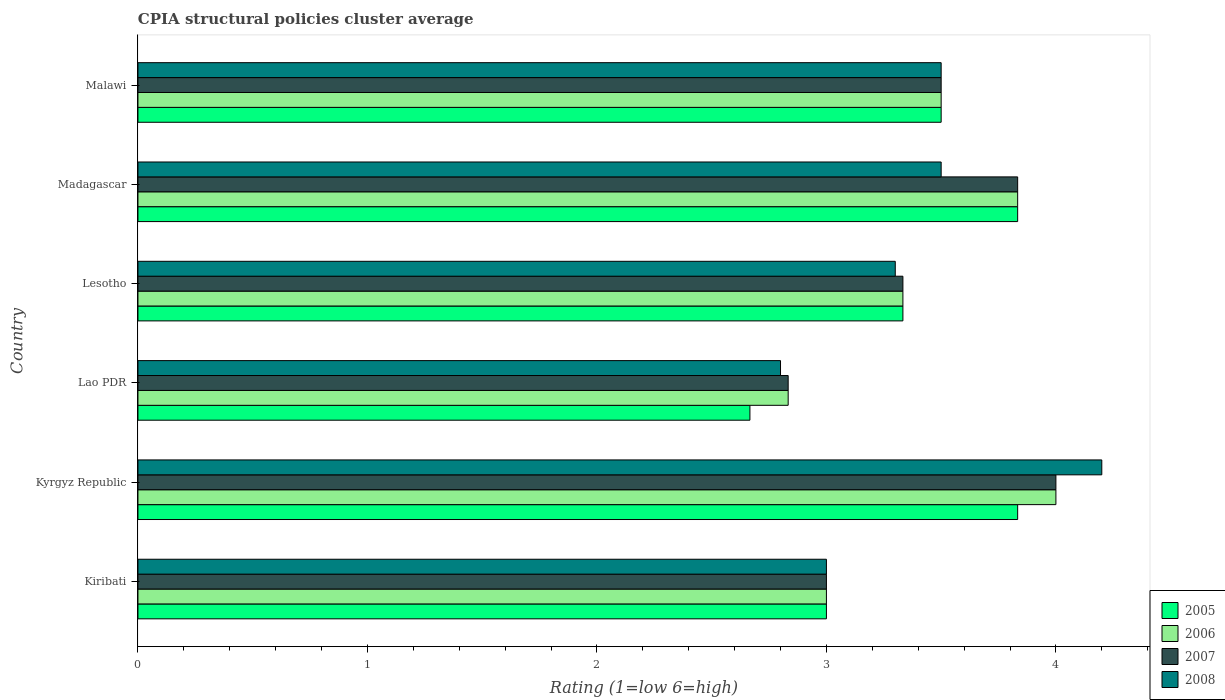How many different coloured bars are there?
Give a very brief answer. 4. How many groups of bars are there?
Your answer should be compact. 6. Are the number of bars per tick equal to the number of legend labels?
Ensure brevity in your answer.  Yes. How many bars are there on the 5th tick from the bottom?
Make the answer very short. 4. What is the label of the 3rd group of bars from the top?
Offer a terse response. Lesotho. What is the CPIA rating in 2005 in Kyrgyz Republic?
Your answer should be compact. 3.83. Across all countries, what is the minimum CPIA rating in 2006?
Give a very brief answer. 2.83. In which country was the CPIA rating in 2007 maximum?
Make the answer very short. Kyrgyz Republic. In which country was the CPIA rating in 2008 minimum?
Keep it short and to the point. Lao PDR. What is the total CPIA rating in 2005 in the graph?
Your answer should be compact. 20.17. What is the difference between the CPIA rating in 2006 in Lesotho and the CPIA rating in 2008 in Kiribati?
Your answer should be compact. 0.33. What is the average CPIA rating in 2007 per country?
Offer a terse response. 3.42. What is the difference between the CPIA rating in 2008 and CPIA rating in 2005 in Kyrgyz Republic?
Make the answer very short. 0.37. What is the ratio of the CPIA rating in 2005 in Madagascar to that in Malawi?
Provide a short and direct response. 1.1. Is the CPIA rating in 2005 in Lesotho less than that in Madagascar?
Your answer should be compact. Yes. Is the difference between the CPIA rating in 2008 in Kiribati and Kyrgyz Republic greater than the difference between the CPIA rating in 2005 in Kiribati and Kyrgyz Republic?
Give a very brief answer. No. What is the difference between the highest and the second highest CPIA rating in 2008?
Provide a succinct answer. 0.7. What is the difference between the highest and the lowest CPIA rating in 2008?
Ensure brevity in your answer.  1.4. What does the 3rd bar from the top in Lao PDR represents?
Your response must be concise. 2006. Is it the case that in every country, the sum of the CPIA rating in 2007 and CPIA rating in 2006 is greater than the CPIA rating in 2005?
Provide a short and direct response. Yes. Are all the bars in the graph horizontal?
Your response must be concise. Yes. How many countries are there in the graph?
Make the answer very short. 6. What is the difference between two consecutive major ticks on the X-axis?
Make the answer very short. 1. Are the values on the major ticks of X-axis written in scientific E-notation?
Give a very brief answer. No. Where does the legend appear in the graph?
Provide a short and direct response. Bottom right. How many legend labels are there?
Offer a very short reply. 4. What is the title of the graph?
Provide a short and direct response. CPIA structural policies cluster average. What is the label or title of the X-axis?
Keep it short and to the point. Rating (1=low 6=high). What is the Rating (1=low 6=high) in 2005 in Kiribati?
Offer a terse response. 3. What is the Rating (1=low 6=high) of 2006 in Kiribati?
Offer a terse response. 3. What is the Rating (1=low 6=high) of 2005 in Kyrgyz Republic?
Keep it short and to the point. 3.83. What is the Rating (1=low 6=high) of 2006 in Kyrgyz Republic?
Your response must be concise. 4. What is the Rating (1=low 6=high) of 2008 in Kyrgyz Republic?
Provide a short and direct response. 4.2. What is the Rating (1=low 6=high) in 2005 in Lao PDR?
Give a very brief answer. 2.67. What is the Rating (1=low 6=high) of 2006 in Lao PDR?
Offer a very short reply. 2.83. What is the Rating (1=low 6=high) of 2007 in Lao PDR?
Offer a very short reply. 2.83. What is the Rating (1=low 6=high) in 2008 in Lao PDR?
Your answer should be very brief. 2.8. What is the Rating (1=low 6=high) in 2005 in Lesotho?
Your answer should be compact. 3.33. What is the Rating (1=low 6=high) of 2006 in Lesotho?
Provide a short and direct response. 3.33. What is the Rating (1=low 6=high) in 2007 in Lesotho?
Give a very brief answer. 3.33. What is the Rating (1=low 6=high) in 2008 in Lesotho?
Provide a succinct answer. 3.3. What is the Rating (1=low 6=high) of 2005 in Madagascar?
Offer a very short reply. 3.83. What is the Rating (1=low 6=high) of 2006 in Madagascar?
Ensure brevity in your answer.  3.83. What is the Rating (1=low 6=high) in 2007 in Madagascar?
Offer a very short reply. 3.83. What is the Rating (1=low 6=high) of 2008 in Madagascar?
Offer a terse response. 3.5. What is the Rating (1=low 6=high) in 2006 in Malawi?
Give a very brief answer. 3.5. What is the Rating (1=low 6=high) of 2008 in Malawi?
Your response must be concise. 3.5. Across all countries, what is the maximum Rating (1=low 6=high) in 2005?
Offer a very short reply. 3.83. Across all countries, what is the maximum Rating (1=low 6=high) in 2007?
Your response must be concise. 4. Across all countries, what is the minimum Rating (1=low 6=high) of 2005?
Give a very brief answer. 2.67. Across all countries, what is the minimum Rating (1=low 6=high) of 2006?
Keep it short and to the point. 2.83. Across all countries, what is the minimum Rating (1=low 6=high) of 2007?
Give a very brief answer. 2.83. What is the total Rating (1=low 6=high) of 2005 in the graph?
Provide a succinct answer. 20.17. What is the total Rating (1=low 6=high) of 2006 in the graph?
Keep it short and to the point. 20.5. What is the total Rating (1=low 6=high) of 2008 in the graph?
Your response must be concise. 20.3. What is the difference between the Rating (1=low 6=high) in 2005 in Kiribati and that in Kyrgyz Republic?
Keep it short and to the point. -0.83. What is the difference between the Rating (1=low 6=high) in 2006 in Kiribati and that in Kyrgyz Republic?
Offer a terse response. -1. What is the difference between the Rating (1=low 6=high) of 2007 in Kiribati and that in Lao PDR?
Ensure brevity in your answer.  0.17. What is the difference between the Rating (1=low 6=high) in 2006 in Kiribati and that in Madagascar?
Offer a very short reply. -0.83. What is the difference between the Rating (1=low 6=high) of 2007 in Kiribati and that in Madagascar?
Offer a terse response. -0.83. What is the difference between the Rating (1=low 6=high) in 2007 in Kiribati and that in Malawi?
Provide a succinct answer. -0.5. What is the difference between the Rating (1=low 6=high) in 2008 in Kiribati and that in Malawi?
Give a very brief answer. -0.5. What is the difference between the Rating (1=low 6=high) of 2006 in Kyrgyz Republic and that in Lao PDR?
Your response must be concise. 1.17. What is the difference between the Rating (1=low 6=high) of 2007 in Kyrgyz Republic and that in Lao PDR?
Your answer should be compact. 1.17. What is the difference between the Rating (1=low 6=high) of 2008 in Kyrgyz Republic and that in Lao PDR?
Provide a short and direct response. 1.4. What is the difference between the Rating (1=low 6=high) of 2005 in Kyrgyz Republic and that in Madagascar?
Keep it short and to the point. 0. What is the difference between the Rating (1=low 6=high) in 2006 in Kyrgyz Republic and that in Madagascar?
Ensure brevity in your answer.  0.17. What is the difference between the Rating (1=low 6=high) in 2008 in Kyrgyz Republic and that in Madagascar?
Your response must be concise. 0.7. What is the difference between the Rating (1=low 6=high) in 2005 in Kyrgyz Republic and that in Malawi?
Provide a succinct answer. 0.33. What is the difference between the Rating (1=low 6=high) of 2008 in Kyrgyz Republic and that in Malawi?
Keep it short and to the point. 0.7. What is the difference between the Rating (1=low 6=high) of 2005 in Lao PDR and that in Lesotho?
Your answer should be compact. -0.67. What is the difference between the Rating (1=low 6=high) in 2006 in Lao PDR and that in Lesotho?
Keep it short and to the point. -0.5. What is the difference between the Rating (1=low 6=high) in 2007 in Lao PDR and that in Lesotho?
Your response must be concise. -0.5. What is the difference between the Rating (1=low 6=high) of 2008 in Lao PDR and that in Lesotho?
Give a very brief answer. -0.5. What is the difference between the Rating (1=low 6=high) in 2005 in Lao PDR and that in Madagascar?
Your answer should be compact. -1.17. What is the difference between the Rating (1=low 6=high) of 2007 in Lao PDR and that in Madagascar?
Ensure brevity in your answer.  -1. What is the difference between the Rating (1=low 6=high) in 2008 in Lao PDR and that in Madagascar?
Give a very brief answer. -0.7. What is the difference between the Rating (1=low 6=high) of 2005 in Lao PDR and that in Malawi?
Your answer should be compact. -0.83. What is the difference between the Rating (1=low 6=high) in 2007 in Lao PDR and that in Malawi?
Your answer should be very brief. -0.67. What is the difference between the Rating (1=low 6=high) of 2008 in Lesotho and that in Madagascar?
Ensure brevity in your answer.  -0.2. What is the difference between the Rating (1=low 6=high) of 2005 in Lesotho and that in Malawi?
Give a very brief answer. -0.17. What is the difference between the Rating (1=low 6=high) in 2006 in Lesotho and that in Malawi?
Offer a very short reply. -0.17. What is the difference between the Rating (1=low 6=high) of 2007 in Lesotho and that in Malawi?
Provide a short and direct response. -0.17. What is the difference between the Rating (1=low 6=high) in 2008 in Lesotho and that in Malawi?
Provide a succinct answer. -0.2. What is the difference between the Rating (1=low 6=high) in 2006 in Madagascar and that in Malawi?
Your answer should be compact. 0.33. What is the difference between the Rating (1=low 6=high) in 2007 in Madagascar and that in Malawi?
Make the answer very short. 0.33. What is the difference between the Rating (1=low 6=high) of 2008 in Madagascar and that in Malawi?
Your answer should be compact. 0. What is the difference between the Rating (1=low 6=high) in 2005 in Kiribati and the Rating (1=low 6=high) in 2006 in Kyrgyz Republic?
Give a very brief answer. -1. What is the difference between the Rating (1=low 6=high) in 2005 in Kiribati and the Rating (1=low 6=high) in 2007 in Kyrgyz Republic?
Offer a terse response. -1. What is the difference between the Rating (1=low 6=high) of 2005 in Kiribati and the Rating (1=low 6=high) of 2008 in Kyrgyz Republic?
Provide a succinct answer. -1.2. What is the difference between the Rating (1=low 6=high) of 2006 in Kiribati and the Rating (1=low 6=high) of 2007 in Kyrgyz Republic?
Your answer should be very brief. -1. What is the difference between the Rating (1=low 6=high) of 2007 in Kiribati and the Rating (1=low 6=high) of 2008 in Kyrgyz Republic?
Provide a succinct answer. -1.2. What is the difference between the Rating (1=low 6=high) of 2006 in Kiribati and the Rating (1=low 6=high) of 2007 in Lao PDR?
Ensure brevity in your answer.  0.17. What is the difference between the Rating (1=low 6=high) in 2007 in Kiribati and the Rating (1=low 6=high) in 2008 in Lao PDR?
Provide a succinct answer. 0.2. What is the difference between the Rating (1=low 6=high) of 2005 in Kiribati and the Rating (1=low 6=high) of 2007 in Lesotho?
Give a very brief answer. -0.33. What is the difference between the Rating (1=low 6=high) of 2006 in Kiribati and the Rating (1=low 6=high) of 2008 in Lesotho?
Provide a succinct answer. -0.3. What is the difference between the Rating (1=low 6=high) in 2007 in Kiribati and the Rating (1=low 6=high) in 2008 in Lesotho?
Your answer should be compact. -0.3. What is the difference between the Rating (1=low 6=high) in 2005 in Kiribati and the Rating (1=low 6=high) in 2008 in Madagascar?
Ensure brevity in your answer.  -0.5. What is the difference between the Rating (1=low 6=high) of 2006 in Kiribati and the Rating (1=low 6=high) of 2007 in Madagascar?
Offer a terse response. -0.83. What is the difference between the Rating (1=low 6=high) of 2006 in Kiribati and the Rating (1=low 6=high) of 2008 in Madagascar?
Keep it short and to the point. -0.5. What is the difference between the Rating (1=low 6=high) in 2007 in Kiribati and the Rating (1=low 6=high) in 2008 in Madagascar?
Give a very brief answer. -0.5. What is the difference between the Rating (1=low 6=high) in 2006 in Kiribati and the Rating (1=low 6=high) in 2007 in Malawi?
Give a very brief answer. -0.5. What is the difference between the Rating (1=low 6=high) in 2007 in Kiribati and the Rating (1=low 6=high) in 2008 in Malawi?
Give a very brief answer. -0.5. What is the difference between the Rating (1=low 6=high) of 2005 in Kyrgyz Republic and the Rating (1=low 6=high) of 2008 in Lao PDR?
Provide a short and direct response. 1.03. What is the difference between the Rating (1=low 6=high) in 2007 in Kyrgyz Republic and the Rating (1=low 6=high) in 2008 in Lao PDR?
Ensure brevity in your answer.  1.2. What is the difference between the Rating (1=low 6=high) in 2005 in Kyrgyz Republic and the Rating (1=low 6=high) in 2006 in Lesotho?
Provide a succinct answer. 0.5. What is the difference between the Rating (1=low 6=high) in 2005 in Kyrgyz Republic and the Rating (1=low 6=high) in 2007 in Lesotho?
Offer a terse response. 0.5. What is the difference between the Rating (1=low 6=high) of 2005 in Kyrgyz Republic and the Rating (1=low 6=high) of 2008 in Lesotho?
Your answer should be very brief. 0.53. What is the difference between the Rating (1=low 6=high) in 2006 in Kyrgyz Republic and the Rating (1=low 6=high) in 2007 in Lesotho?
Provide a succinct answer. 0.67. What is the difference between the Rating (1=low 6=high) in 2005 in Kyrgyz Republic and the Rating (1=low 6=high) in 2006 in Madagascar?
Your answer should be very brief. 0. What is the difference between the Rating (1=low 6=high) of 2005 in Kyrgyz Republic and the Rating (1=low 6=high) of 2007 in Madagascar?
Keep it short and to the point. 0. What is the difference between the Rating (1=low 6=high) of 2005 in Kyrgyz Republic and the Rating (1=low 6=high) of 2007 in Malawi?
Your answer should be very brief. 0.33. What is the difference between the Rating (1=low 6=high) of 2006 in Kyrgyz Republic and the Rating (1=low 6=high) of 2007 in Malawi?
Keep it short and to the point. 0.5. What is the difference between the Rating (1=low 6=high) in 2005 in Lao PDR and the Rating (1=low 6=high) in 2006 in Lesotho?
Provide a succinct answer. -0.67. What is the difference between the Rating (1=low 6=high) of 2005 in Lao PDR and the Rating (1=low 6=high) of 2007 in Lesotho?
Ensure brevity in your answer.  -0.67. What is the difference between the Rating (1=low 6=high) of 2005 in Lao PDR and the Rating (1=low 6=high) of 2008 in Lesotho?
Offer a terse response. -0.63. What is the difference between the Rating (1=low 6=high) of 2006 in Lao PDR and the Rating (1=low 6=high) of 2008 in Lesotho?
Keep it short and to the point. -0.47. What is the difference between the Rating (1=low 6=high) of 2007 in Lao PDR and the Rating (1=low 6=high) of 2008 in Lesotho?
Offer a terse response. -0.47. What is the difference between the Rating (1=low 6=high) of 2005 in Lao PDR and the Rating (1=low 6=high) of 2006 in Madagascar?
Ensure brevity in your answer.  -1.17. What is the difference between the Rating (1=low 6=high) of 2005 in Lao PDR and the Rating (1=low 6=high) of 2007 in Madagascar?
Your answer should be compact. -1.17. What is the difference between the Rating (1=low 6=high) of 2006 in Lao PDR and the Rating (1=low 6=high) of 2007 in Madagascar?
Offer a very short reply. -1. What is the difference between the Rating (1=low 6=high) in 2005 in Lao PDR and the Rating (1=low 6=high) in 2008 in Malawi?
Keep it short and to the point. -0.83. What is the difference between the Rating (1=low 6=high) in 2006 in Lao PDR and the Rating (1=low 6=high) in 2008 in Malawi?
Ensure brevity in your answer.  -0.67. What is the difference between the Rating (1=low 6=high) in 2005 in Lesotho and the Rating (1=low 6=high) in 2006 in Madagascar?
Your answer should be very brief. -0.5. What is the difference between the Rating (1=low 6=high) of 2005 in Lesotho and the Rating (1=low 6=high) of 2007 in Madagascar?
Give a very brief answer. -0.5. What is the difference between the Rating (1=low 6=high) in 2005 in Lesotho and the Rating (1=low 6=high) in 2008 in Madagascar?
Your answer should be compact. -0.17. What is the difference between the Rating (1=low 6=high) in 2006 in Lesotho and the Rating (1=low 6=high) in 2007 in Madagascar?
Offer a terse response. -0.5. What is the difference between the Rating (1=low 6=high) of 2007 in Lesotho and the Rating (1=low 6=high) of 2008 in Madagascar?
Provide a succinct answer. -0.17. What is the difference between the Rating (1=low 6=high) of 2005 in Lesotho and the Rating (1=low 6=high) of 2006 in Malawi?
Give a very brief answer. -0.17. What is the difference between the Rating (1=low 6=high) in 2006 in Lesotho and the Rating (1=low 6=high) in 2008 in Malawi?
Make the answer very short. -0.17. What is the difference between the Rating (1=low 6=high) in 2007 in Lesotho and the Rating (1=low 6=high) in 2008 in Malawi?
Your answer should be very brief. -0.17. What is the difference between the Rating (1=low 6=high) in 2005 in Madagascar and the Rating (1=low 6=high) in 2007 in Malawi?
Keep it short and to the point. 0.33. What is the difference between the Rating (1=low 6=high) in 2005 in Madagascar and the Rating (1=low 6=high) in 2008 in Malawi?
Provide a succinct answer. 0.33. What is the difference between the Rating (1=low 6=high) in 2006 in Madagascar and the Rating (1=low 6=high) in 2008 in Malawi?
Offer a terse response. 0.33. What is the average Rating (1=low 6=high) in 2005 per country?
Keep it short and to the point. 3.36. What is the average Rating (1=low 6=high) in 2006 per country?
Make the answer very short. 3.42. What is the average Rating (1=low 6=high) of 2007 per country?
Keep it short and to the point. 3.42. What is the average Rating (1=low 6=high) in 2008 per country?
Provide a short and direct response. 3.38. What is the difference between the Rating (1=low 6=high) of 2005 and Rating (1=low 6=high) of 2008 in Kiribati?
Your response must be concise. 0. What is the difference between the Rating (1=low 6=high) in 2006 and Rating (1=low 6=high) in 2007 in Kiribati?
Offer a very short reply. 0. What is the difference between the Rating (1=low 6=high) of 2005 and Rating (1=low 6=high) of 2006 in Kyrgyz Republic?
Ensure brevity in your answer.  -0.17. What is the difference between the Rating (1=low 6=high) of 2005 and Rating (1=low 6=high) of 2008 in Kyrgyz Republic?
Make the answer very short. -0.37. What is the difference between the Rating (1=low 6=high) in 2006 and Rating (1=low 6=high) in 2007 in Kyrgyz Republic?
Keep it short and to the point. 0. What is the difference between the Rating (1=low 6=high) in 2005 and Rating (1=low 6=high) in 2006 in Lao PDR?
Give a very brief answer. -0.17. What is the difference between the Rating (1=low 6=high) of 2005 and Rating (1=low 6=high) of 2007 in Lao PDR?
Provide a succinct answer. -0.17. What is the difference between the Rating (1=low 6=high) of 2005 and Rating (1=low 6=high) of 2008 in Lao PDR?
Provide a succinct answer. -0.13. What is the difference between the Rating (1=low 6=high) in 2006 and Rating (1=low 6=high) in 2007 in Lao PDR?
Ensure brevity in your answer.  0. What is the difference between the Rating (1=low 6=high) in 2007 and Rating (1=low 6=high) in 2008 in Lao PDR?
Give a very brief answer. 0.03. What is the difference between the Rating (1=low 6=high) in 2005 and Rating (1=low 6=high) in 2007 in Lesotho?
Make the answer very short. 0. What is the difference between the Rating (1=low 6=high) of 2006 and Rating (1=low 6=high) of 2007 in Lesotho?
Your response must be concise. 0. What is the difference between the Rating (1=low 6=high) in 2005 and Rating (1=low 6=high) in 2007 in Madagascar?
Offer a terse response. 0. What is the difference between the Rating (1=low 6=high) of 2006 and Rating (1=low 6=high) of 2007 in Madagascar?
Give a very brief answer. 0. What is the difference between the Rating (1=low 6=high) in 2005 and Rating (1=low 6=high) in 2006 in Malawi?
Your answer should be compact. 0. What is the difference between the Rating (1=low 6=high) of 2005 and Rating (1=low 6=high) of 2007 in Malawi?
Provide a succinct answer. 0. What is the difference between the Rating (1=low 6=high) of 2005 and Rating (1=low 6=high) of 2008 in Malawi?
Provide a succinct answer. 0. What is the difference between the Rating (1=low 6=high) of 2006 and Rating (1=low 6=high) of 2007 in Malawi?
Offer a terse response. 0. What is the difference between the Rating (1=low 6=high) in 2006 and Rating (1=low 6=high) in 2008 in Malawi?
Give a very brief answer. 0. What is the ratio of the Rating (1=low 6=high) of 2005 in Kiribati to that in Kyrgyz Republic?
Offer a very short reply. 0.78. What is the ratio of the Rating (1=low 6=high) of 2006 in Kiribati to that in Kyrgyz Republic?
Your answer should be very brief. 0.75. What is the ratio of the Rating (1=low 6=high) of 2008 in Kiribati to that in Kyrgyz Republic?
Provide a succinct answer. 0.71. What is the ratio of the Rating (1=low 6=high) of 2005 in Kiribati to that in Lao PDR?
Your response must be concise. 1.12. What is the ratio of the Rating (1=low 6=high) in 2006 in Kiribati to that in Lao PDR?
Provide a succinct answer. 1.06. What is the ratio of the Rating (1=low 6=high) in 2007 in Kiribati to that in Lao PDR?
Offer a very short reply. 1.06. What is the ratio of the Rating (1=low 6=high) of 2008 in Kiribati to that in Lao PDR?
Give a very brief answer. 1.07. What is the ratio of the Rating (1=low 6=high) in 2006 in Kiribati to that in Lesotho?
Your answer should be compact. 0.9. What is the ratio of the Rating (1=low 6=high) in 2005 in Kiribati to that in Madagascar?
Provide a short and direct response. 0.78. What is the ratio of the Rating (1=low 6=high) of 2006 in Kiribati to that in Madagascar?
Make the answer very short. 0.78. What is the ratio of the Rating (1=low 6=high) of 2007 in Kiribati to that in Madagascar?
Make the answer very short. 0.78. What is the ratio of the Rating (1=low 6=high) of 2005 in Kyrgyz Republic to that in Lao PDR?
Keep it short and to the point. 1.44. What is the ratio of the Rating (1=low 6=high) in 2006 in Kyrgyz Republic to that in Lao PDR?
Provide a short and direct response. 1.41. What is the ratio of the Rating (1=low 6=high) of 2007 in Kyrgyz Republic to that in Lao PDR?
Your response must be concise. 1.41. What is the ratio of the Rating (1=low 6=high) in 2005 in Kyrgyz Republic to that in Lesotho?
Keep it short and to the point. 1.15. What is the ratio of the Rating (1=low 6=high) of 2008 in Kyrgyz Republic to that in Lesotho?
Keep it short and to the point. 1.27. What is the ratio of the Rating (1=low 6=high) in 2006 in Kyrgyz Republic to that in Madagascar?
Offer a terse response. 1.04. What is the ratio of the Rating (1=low 6=high) in 2007 in Kyrgyz Republic to that in Madagascar?
Provide a succinct answer. 1.04. What is the ratio of the Rating (1=low 6=high) in 2005 in Kyrgyz Republic to that in Malawi?
Make the answer very short. 1.1. What is the ratio of the Rating (1=low 6=high) in 2008 in Lao PDR to that in Lesotho?
Provide a short and direct response. 0.85. What is the ratio of the Rating (1=low 6=high) of 2005 in Lao PDR to that in Madagascar?
Offer a very short reply. 0.7. What is the ratio of the Rating (1=low 6=high) in 2006 in Lao PDR to that in Madagascar?
Offer a terse response. 0.74. What is the ratio of the Rating (1=low 6=high) of 2007 in Lao PDR to that in Madagascar?
Make the answer very short. 0.74. What is the ratio of the Rating (1=low 6=high) in 2005 in Lao PDR to that in Malawi?
Offer a very short reply. 0.76. What is the ratio of the Rating (1=low 6=high) in 2006 in Lao PDR to that in Malawi?
Provide a succinct answer. 0.81. What is the ratio of the Rating (1=low 6=high) of 2007 in Lao PDR to that in Malawi?
Provide a short and direct response. 0.81. What is the ratio of the Rating (1=low 6=high) of 2008 in Lao PDR to that in Malawi?
Offer a very short reply. 0.8. What is the ratio of the Rating (1=low 6=high) in 2005 in Lesotho to that in Madagascar?
Keep it short and to the point. 0.87. What is the ratio of the Rating (1=low 6=high) in 2006 in Lesotho to that in Madagascar?
Keep it short and to the point. 0.87. What is the ratio of the Rating (1=low 6=high) in 2007 in Lesotho to that in Madagascar?
Offer a terse response. 0.87. What is the ratio of the Rating (1=low 6=high) in 2008 in Lesotho to that in Madagascar?
Give a very brief answer. 0.94. What is the ratio of the Rating (1=low 6=high) in 2007 in Lesotho to that in Malawi?
Ensure brevity in your answer.  0.95. What is the ratio of the Rating (1=low 6=high) of 2008 in Lesotho to that in Malawi?
Your answer should be very brief. 0.94. What is the ratio of the Rating (1=low 6=high) of 2005 in Madagascar to that in Malawi?
Make the answer very short. 1.1. What is the ratio of the Rating (1=low 6=high) of 2006 in Madagascar to that in Malawi?
Your answer should be very brief. 1.1. What is the ratio of the Rating (1=low 6=high) in 2007 in Madagascar to that in Malawi?
Provide a short and direct response. 1.1. What is the difference between the highest and the second highest Rating (1=low 6=high) in 2007?
Offer a terse response. 0.17. What is the difference between the highest and the lowest Rating (1=low 6=high) of 2006?
Keep it short and to the point. 1.17. What is the difference between the highest and the lowest Rating (1=low 6=high) in 2007?
Provide a succinct answer. 1.17. What is the difference between the highest and the lowest Rating (1=low 6=high) of 2008?
Provide a short and direct response. 1.4. 